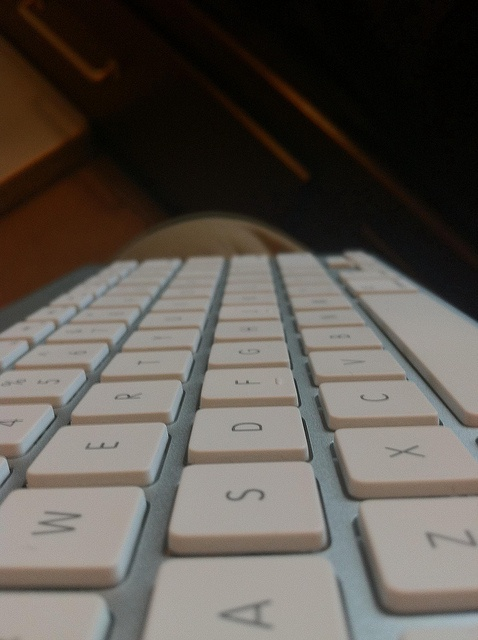Describe the objects in this image and their specific colors. I can see a keyboard in black, darkgray, and gray tones in this image. 